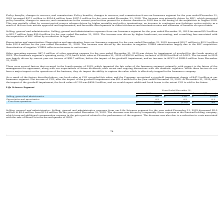According to Hc2 Holdings's financial document, What was the Selling, general and administrative expenses from our Life Sciences segment for the year ended December 31, 2019? According to the financial document, $8.6 million. The relevant text states: "ended December 31, 2019 decreased $5.0 million to $8.6 million from $13.6 million for the year ended December 31, 2018. The decrease was driven by comparably fewer..." Also, What was the decrease in the selling, general and administrative expenses? According to the financial document, $5.0 million. The relevant text states: "ent for the year ended December 31, 2019 decreased $5.0 million to $8.6 million from $13.6 million for the year ended December 31, 2018. The decrease was driven by..." Also, What was the Depreciation and amortization in 2019? According to the financial document, 0.3 (in millions). The relevant text states: "Depreciation and amortization 0.3 0.2 0.1..." Also, can you calculate: What was the percentage change in the selling, general and administrative expenses from 2018 to 2019? To answer this question, I need to perform calculations using the financial data. The calculation is: 8.6 / 13.6 - 1, which equals -36.76 (percentage). This is based on the information: "Selling, general and administrative $ 8.6 $ 13.6 $ (5.0) Selling, general and administrative $ 8.6 $ 13.6 $ (5.0)..." The key data points involved are: 13.6, 8.6. Also, can you calculate: What was the average depreciation and amortization expense for 2018 and 2019? To answer this question, I need to perform calculations using the financial data. The calculation is: (0.3 + 0.2) / 2, which equals 0.25 (in millions). This is based on the information: "Depreciation and amortization 0.3 0.2 0.1 Depreciation and amortization 0.3 0.2 0.1..." The key data points involved are: 0.3. Also, can you calculate: What was the percentage change in the loss from operations from 2018 to 2019? To answer this question, I need to perform calculations using the financial data. The calculation is: -8.9 / -13.8 - 1, which equals -35.51 (percentage). This is based on the information: "Loss from operations $ (8.9) $ (13.8) $ 4.9 ember 31, 2019 of $503.6 million, inclusive of $198.9 million of AOCI. The increase in 2019 was largely driven by current year net income of $98.7 million..." The key data points involved are: 13.8, 8.9. 